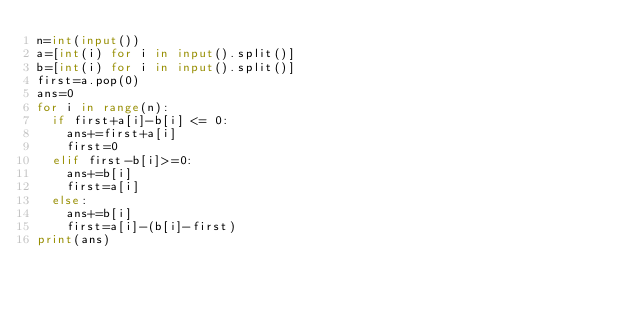<code> <loc_0><loc_0><loc_500><loc_500><_Python_>n=int(input())
a=[int(i) for i in input().split()]
b=[int(i) for i in input().split()]
first=a.pop(0)
ans=0
for i in range(n):
  if first+a[i]-b[i] <= 0:
    ans+=first+a[i]
    first=0
  elif first-b[i]>=0:
    ans+=b[i]
    first=a[i]
  else:
    ans+=b[i]
    first=a[i]-(b[i]-first)
print(ans)    </code> 